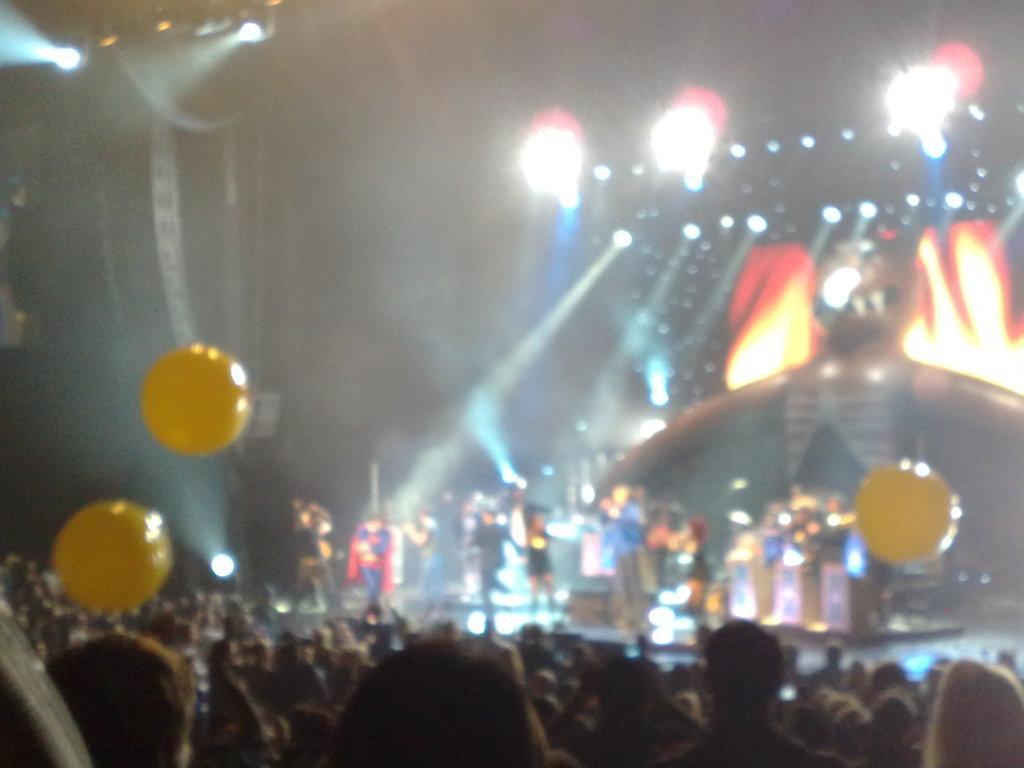Could you give a brief overview of what you see in this image? In this blur image, we can see people, lights and balloons. 